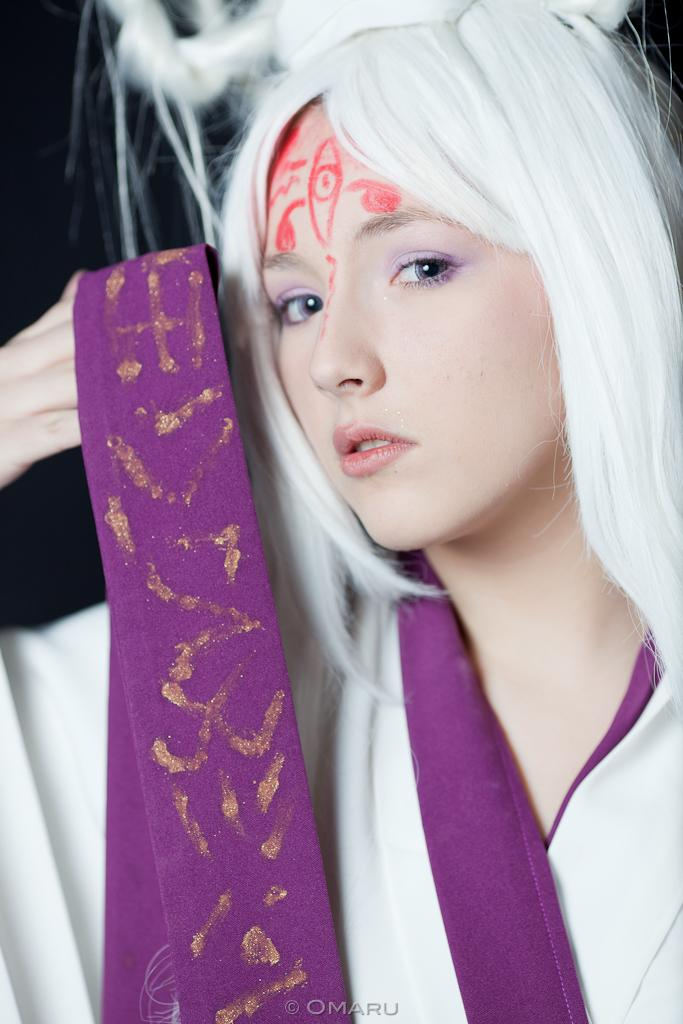Who is the main subject in the image? There is a woman in the image. What is the woman holding in her hand? The woman is holding a cloth or ribbon-like banner in her hand. Can you describe any additional details about the woman's appearance? There is paint on the woman's forehead. What can be seen at the bottom of the image? There is text at the bottom of the image. What type of soda is the woman drinking in the image? There is no soda present in the image; the woman is holding a cloth or ribbon-like banner and has paint on her forehead. What is the purpose of the alarm in the image? There is no alarm present in the image. 